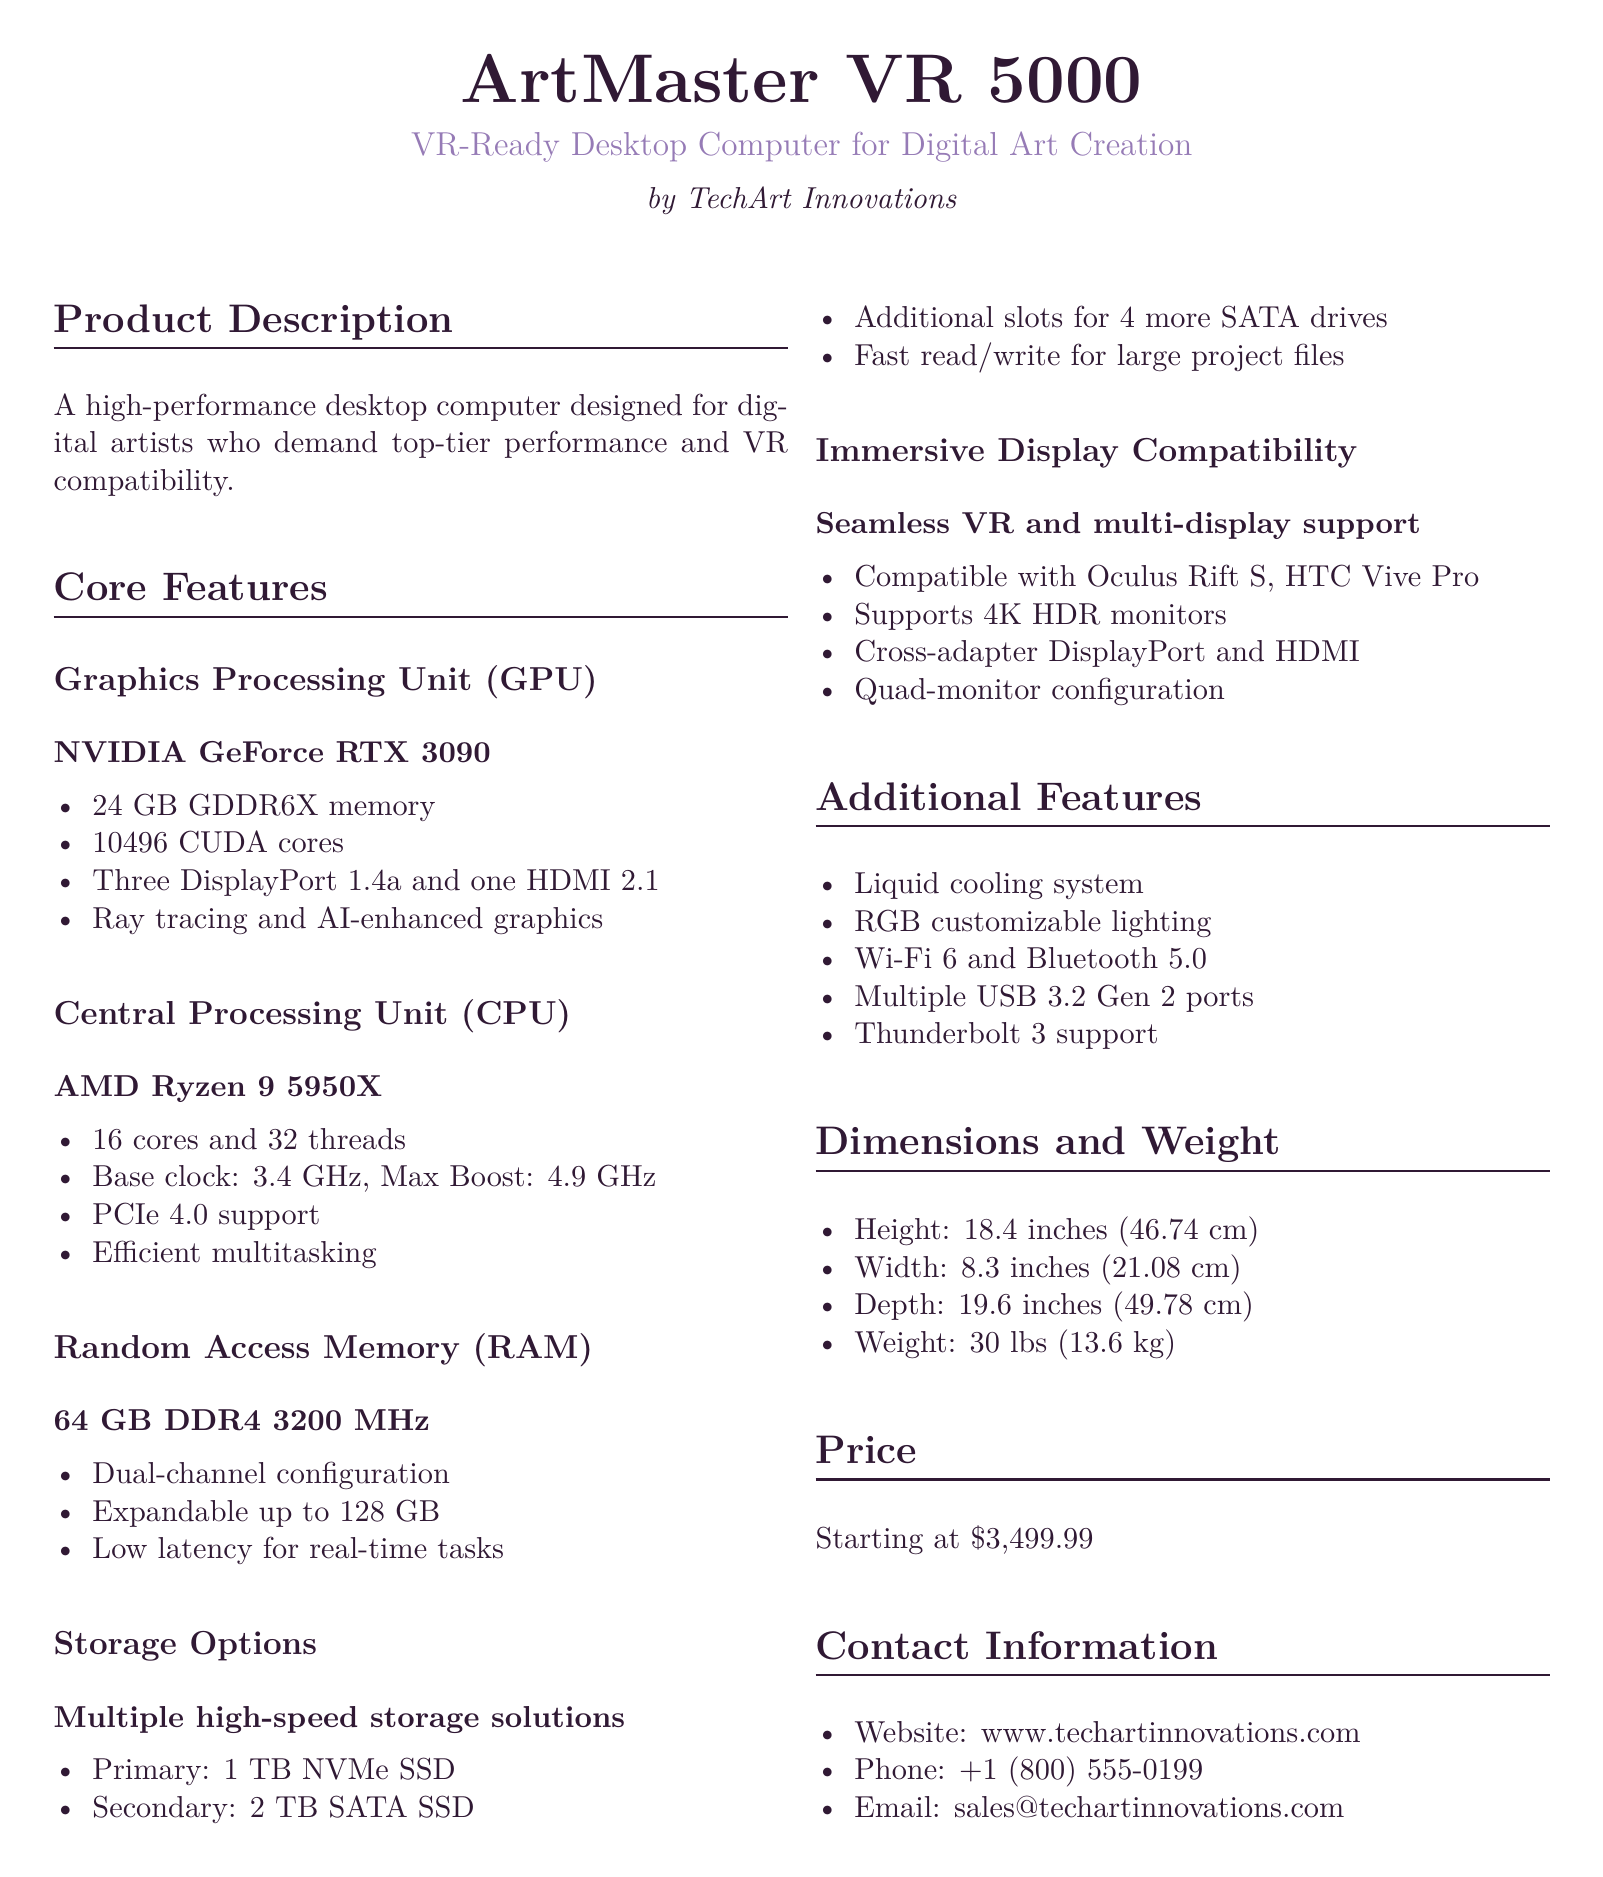what is the model name of the desktop computer? The model name listed in the document is "ArtMaster VR 5000".
Answer: ArtMaster VR 5000 what is the primary GPU used in the product? The document specifies the graphics processing unit used in the product as "NVIDIA GeForce RTX 3090".
Answer: NVIDIA GeForce RTX 3090 how much RAM does the desktop computer have? The amount of RAM mentioned in the document is "64 GB DDR4 3200 MHz".
Answer: 64 GB DDR4 3200 MHz what is the base clock speed of the CPU? The base clock speed of the CPU is indicated as "3.4 GHz".
Answer: 3.4 GHz how many TB of storage does the primary NVMe SSD provide? The capacity of the primary NVMe SSD listed in the document is "1 TB".
Answer: 1 TB how many cores does the CPU have? The document indicates that the CPU has "16 cores".
Answer: 16 cores what is the maximum boost clock speed of the CPU? The maximum boost clock speed mentioned for the CPU is "4.9 GHz".
Answer: 4.9 GHz what type of display support does the computer offer? The document states that it offers "Seamless VR and multi-display support".
Answer: Seamless VR and multi-display support what is the starting price of the desktop computer? The starting price listed in the document is "$3,499.99".
Answer: $3,499.99 